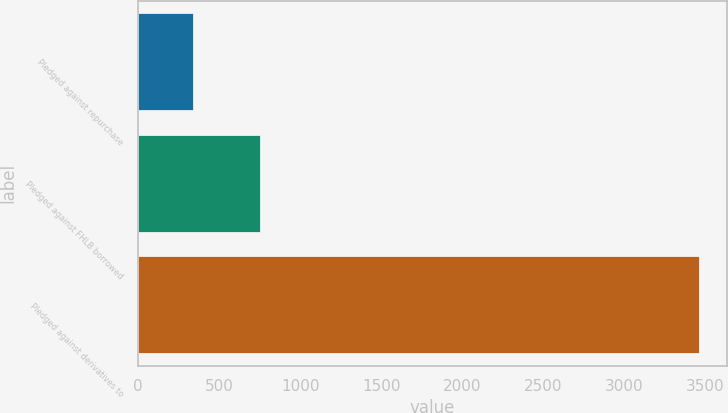Convert chart to OTSL. <chart><loc_0><loc_0><loc_500><loc_500><bar_chart><fcel>Pledged against repurchase<fcel>Pledged against FHLB borrowed<fcel>Pledged against derivatives to<nl><fcel>338<fcel>752<fcel>3460<nl></chart> 